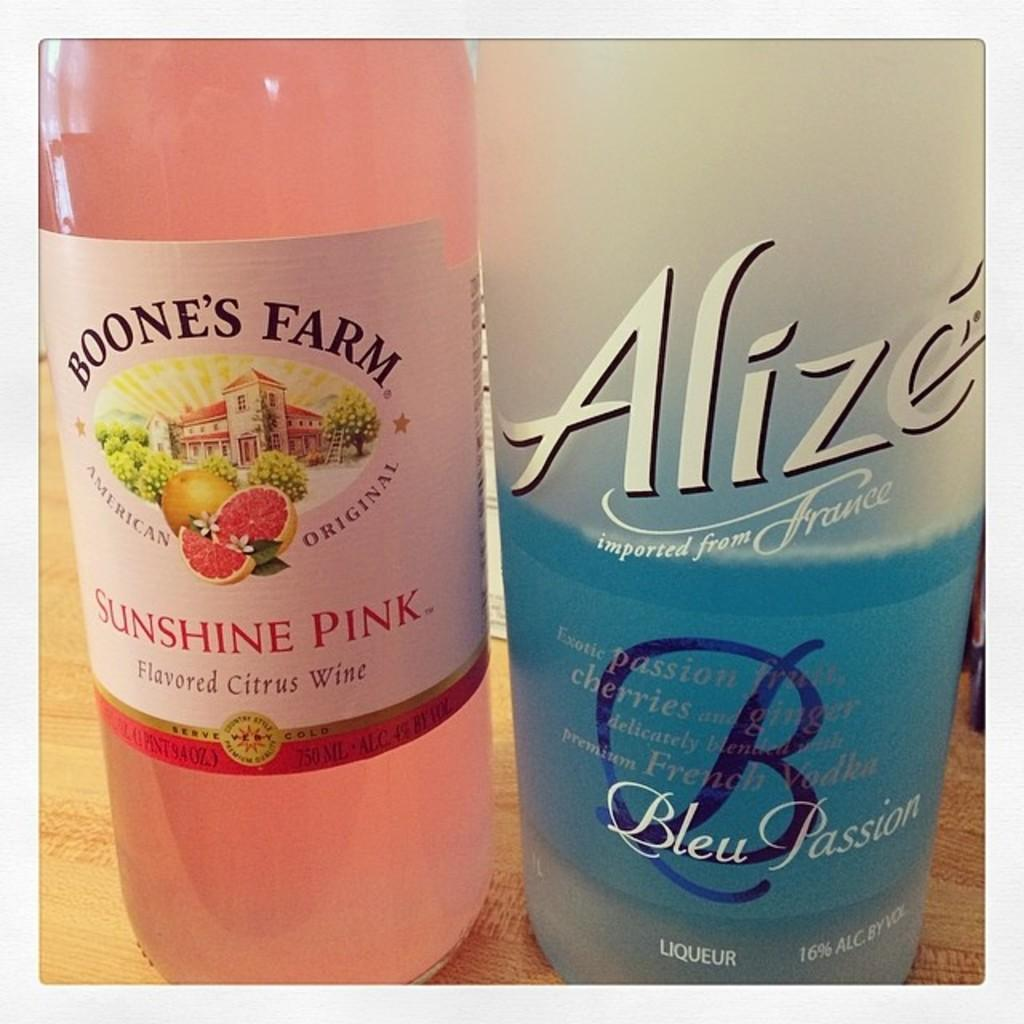How many bottles are visible in the image? There are two bottles in the image. What type of decision is being made by the person wearing a veil in the image? There is no person wearing a veil or making a decision present in the image; it only features two bottles. What color is the pen used by the person in the image? There is no person or pen present in the image; it only features two bottles. 